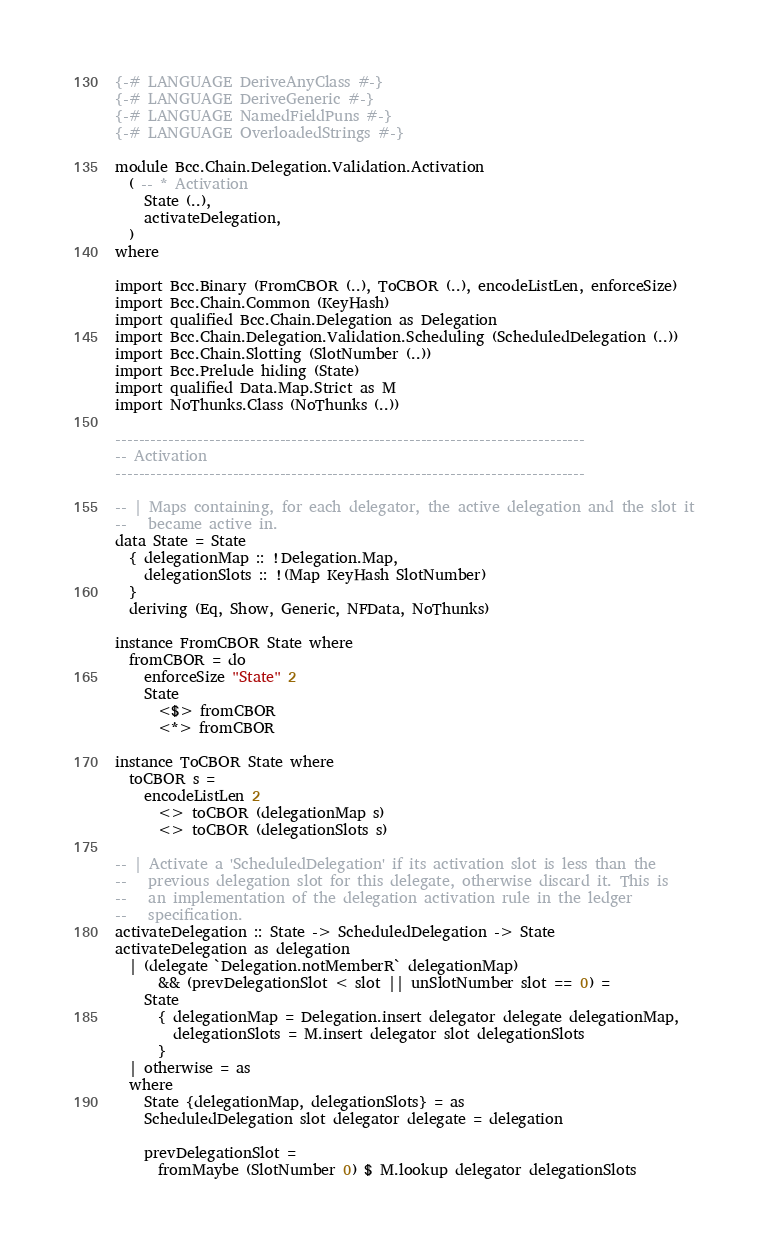<code> <loc_0><loc_0><loc_500><loc_500><_Haskell_>{-# LANGUAGE DeriveAnyClass #-}
{-# LANGUAGE DeriveGeneric #-}
{-# LANGUAGE NamedFieldPuns #-}
{-# LANGUAGE OverloadedStrings #-}

module Bcc.Chain.Delegation.Validation.Activation
  ( -- * Activation
    State (..),
    activateDelegation,
  )
where

import Bcc.Binary (FromCBOR (..), ToCBOR (..), encodeListLen, enforceSize)
import Bcc.Chain.Common (KeyHash)
import qualified Bcc.Chain.Delegation as Delegation
import Bcc.Chain.Delegation.Validation.Scheduling (ScheduledDelegation (..))
import Bcc.Chain.Slotting (SlotNumber (..))
import Bcc.Prelude hiding (State)
import qualified Data.Map.Strict as M
import NoThunks.Class (NoThunks (..))

--------------------------------------------------------------------------------
-- Activation
--------------------------------------------------------------------------------

-- | Maps containing, for each delegator, the active delegation and the slot it
--   became active in.
data State = State
  { delegationMap :: !Delegation.Map,
    delegationSlots :: !(Map KeyHash SlotNumber)
  }
  deriving (Eq, Show, Generic, NFData, NoThunks)

instance FromCBOR State where
  fromCBOR = do
    enforceSize "State" 2
    State
      <$> fromCBOR
      <*> fromCBOR

instance ToCBOR State where
  toCBOR s =
    encodeListLen 2
      <> toCBOR (delegationMap s)
      <> toCBOR (delegationSlots s)

-- | Activate a 'ScheduledDelegation' if its activation slot is less than the
--   previous delegation slot for this delegate, otherwise discard it. This is
--   an implementation of the delegation activation rule in the ledger
--   specification.
activateDelegation :: State -> ScheduledDelegation -> State
activateDelegation as delegation
  | (delegate `Delegation.notMemberR` delegationMap)
      && (prevDelegationSlot < slot || unSlotNumber slot == 0) =
    State
      { delegationMap = Delegation.insert delegator delegate delegationMap,
        delegationSlots = M.insert delegator slot delegationSlots
      }
  | otherwise = as
  where
    State {delegationMap, delegationSlots} = as
    ScheduledDelegation slot delegator delegate = delegation

    prevDelegationSlot =
      fromMaybe (SlotNumber 0) $ M.lookup delegator delegationSlots
</code> 